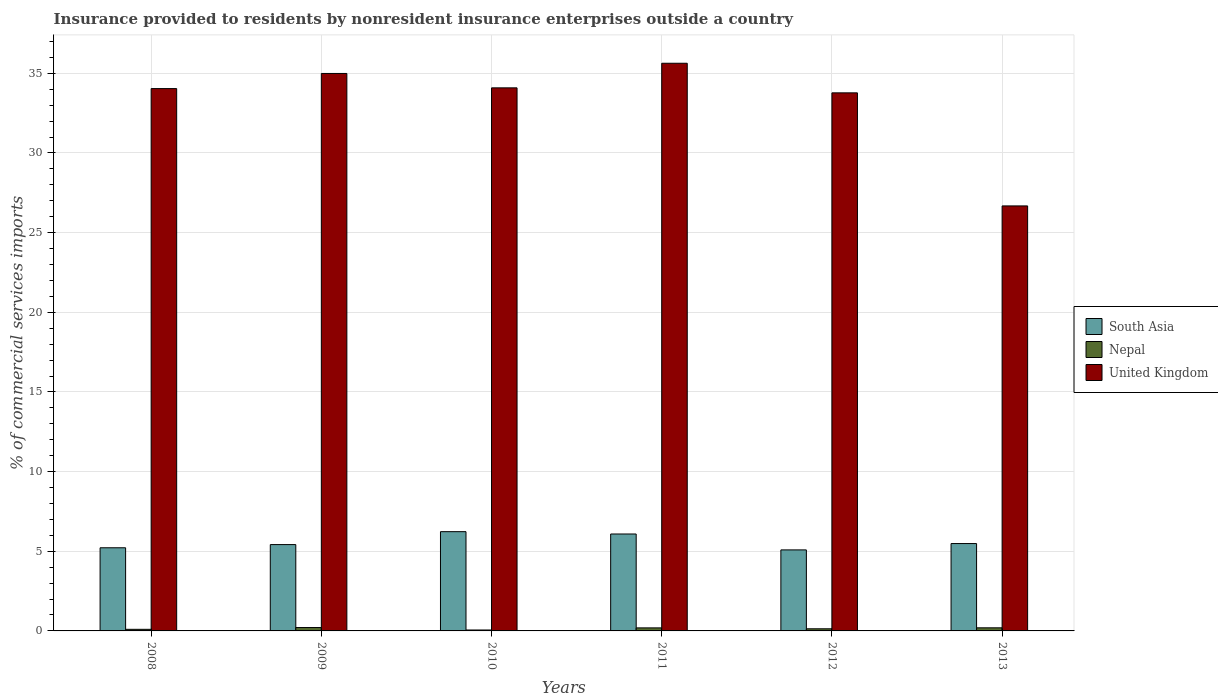How many different coloured bars are there?
Offer a terse response. 3. Are the number of bars per tick equal to the number of legend labels?
Provide a succinct answer. Yes. Are the number of bars on each tick of the X-axis equal?
Give a very brief answer. Yes. How many bars are there on the 3rd tick from the left?
Keep it short and to the point. 3. What is the label of the 2nd group of bars from the left?
Your answer should be very brief. 2009. In how many cases, is the number of bars for a given year not equal to the number of legend labels?
Provide a short and direct response. 0. What is the Insurance provided to residents in United Kingdom in 2008?
Keep it short and to the point. 34.04. Across all years, what is the maximum Insurance provided to residents in South Asia?
Give a very brief answer. 6.23. Across all years, what is the minimum Insurance provided to residents in Nepal?
Give a very brief answer. 0.06. In which year was the Insurance provided to residents in South Asia maximum?
Provide a short and direct response. 2010. In which year was the Insurance provided to residents in United Kingdom minimum?
Provide a succinct answer. 2013. What is the total Insurance provided to residents in Nepal in the graph?
Your response must be concise. 0.89. What is the difference between the Insurance provided to residents in South Asia in 2010 and that in 2012?
Your answer should be very brief. 1.15. What is the difference between the Insurance provided to residents in United Kingdom in 2008 and the Insurance provided to residents in South Asia in 2012?
Provide a short and direct response. 28.96. What is the average Insurance provided to residents in South Asia per year?
Offer a very short reply. 5.59. In the year 2012, what is the difference between the Insurance provided to residents in Nepal and Insurance provided to residents in United Kingdom?
Offer a very short reply. -33.64. What is the ratio of the Insurance provided to residents in United Kingdom in 2012 to that in 2013?
Your answer should be very brief. 1.27. What is the difference between the highest and the second highest Insurance provided to residents in United Kingdom?
Give a very brief answer. 0.64. What is the difference between the highest and the lowest Insurance provided to residents in South Asia?
Make the answer very short. 1.15. In how many years, is the Insurance provided to residents in Nepal greater than the average Insurance provided to residents in Nepal taken over all years?
Give a very brief answer. 3. How many bars are there?
Make the answer very short. 18. Are all the bars in the graph horizontal?
Your answer should be very brief. No. Does the graph contain grids?
Offer a terse response. Yes. How many legend labels are there?
Offer a very short reply. 3. What is the title of the graph?
Keep it short and to the point. Insurance provided to residents by nonresident insurance enterprises outside a country. Does "Haiti" appear as one of the legend labels in the graph?
Your answer should be very brief. No. What is the label or title of the Y-axis?
Offer a very short reply. % of commercial services imports. What is the % of commercial services imports in South Asia in 2008?
Provide a succinct answer. 5.22. What is the % of commercial services imports in Nepal in 2008?
Provide a short and direct response. 0.1. What is the % of commercial services imports in United Kingdom in 2008?
Ensure brevity in your answer.  34.04. What is the % of commercial services imports in South Asia in 2009?
Your response must be concise. 5.42. What is the % of commercial services imports in Nepal in 2009?
Your answer should be very brief. 0.21. What is the % of commercial services imports of United Kingdom in 2009?
Ensure brevity in your answer.  34.99. What is the % of commercial services imports in South Asia in 2010?
Your response must be concise. 6.23. What is the % of commercial services imports in Nepal in 2010?
Your answer should be compact. 0.06. What is the % of commercial services imports of United Kingdom in 2010?
Your answer should be compact. 34.09. What is the % of commercial services imports in South Asia in 2011?
Provide a succinct answer. 6.08. What is the % of commercial services imports of Nepal in 2011?
Provide a succinct answer. 0.19. What is the % of commercial services imports in United Kingdom in 2011?
Ensure brevity in your answer.  35.63. What is the % of commercial services imports of South Asia in 2012?
Your answer should be compact. 5.09. What is the % of commercial services imports in Nepal in 2012?
Ensure brevity in your answer.  0.13. What is the % of commercial services imports of United Kingdom in 2012?
Offer a terse response. 33.77. What is the % of commercial services imports in South Asia in 2013?
Your answer should be compact. 5.48. What is the % of commercial services imports in Nepal in 2013?
Give a very brief answer. 0.2. What is the % of commercial services imports in United Kingdom in 2013?
Provide a succinct answer. 26.68. Across all years, what is the maximum % of commercial services imports of South Asia?
Your answer should be compact. 6.23. Across all years, what is the maximum % of commercial services imports in Nepal?
Provide a succinct answer. 0.21. Across all years, what is the maximum % of commercial services imports of United Kingdom?
Give a very brief answer. 35.63. Across all years, what is the minimum % of commercial services imports of South Asia?
Provide a short and direct response. 5.09. Across all years, what is the minimum % of commercial services imports of Nepal?
Make the answer very short. 0.06. Across all years, what is the minimum % of commercial services imports in United Kingdom?
Your answer should be compact. 26.68. What is the total % of commercial services imports of South Asia in the graph?
Provide a succinct answer. 33.52. What is the total % of commercial services imports in Nepal in the graph?
Keep it short and to the point. 0.89. What is the total % of commercial services imports of United Kingdom in the graph?
Your response must be concise. 199.21. What is the difference between the % of commercial services imports in South Asia in 2008 and that in 2009?
Your answer should be compact. -0.2. What is the difference between the % of commercial services imports of Nepal in 2008 and that in 2009?
Your response must be concise. -0.11. What is the difference between the % of commercial services imports in United Kingdom in 2008 and that in 2009?
Offer a very short reply. -0.95. What is the difference between the % of commercial services imports of South Asia in 2008 and that in 2010?
Your answer should be very brief. -1.01. What is the difference between the % of commercial services imports in Nepal in 2008 and that in 2010?
Your response must be concise. 0.04. What is the difference between the % of commercial services imports in United Kingdom in 2008 and that in 2010?
Provide a short and direct response. -0.05. What is the difference between the % of commercial services imports in South Asia in 2008 and that in 2011?
Your response must be concise. -0.87. What is the difference between the % of commercial services imports of Nepal in 2008 and that in 2011?
Make the answer very short. -0.09. What is the difference between the % of commercial services imports in United Kingdom in 2008 and that in 2011?
Your answer should be compact. -1.59. What is the difference between the % of commercial services imports in South Asia in 2008 and that in 2012?
Ensure brevity in your answer.  0.13. What is the difference between the % of commercial services imports in Nepal in 2008 and that in 2012?
Your answer should be very brief. -0.03. What is the difference between the % of commercial services imports in United Kingdom in 2008 and that in 2012?
Your response must be concise. 0.27. What is the difference between the % of commercial services imports in South Asia in 2008 and that in 2013?
Offer a terse response. -0.26. What is the difference between the % of commercial services imports in Nepal in 2008 and that in 2013?
Ensure brevity in your answer.  -0.09. What is the difference between the % of commercial services imports of United Kingdom in 2008 and that in 2013?
Offer a terse response. 7.36. What is the difference between the % of commercial services imports in South Asia in 2009 and that in 2010?
Provide a succinct answer. -0.81. What is the difference between the % of commercial services imports of Nepal in 2009 and that in 2010?
Make the answer very short. 0.15. What is the difference between the % of commercial services imports in United Kingdom in 2009 and that in 2010?
Your answer should be compact. 0.9. What is the difference between the % of commercial services imports of South Asia in 2009 and that in 2011?
Ensure brevity in your answer.  -0.67. What is the difference between the % of commercial services imports of Nepal in 2009 and that in 2011?
Keep it short and to the point. 0.02. What is the difference between the % of commercial services imports in United Kingdom in 2009 and that in 2011?
Keep it short and to the point. -0.64. What is the difference between the % of commercial services imports of South Asia in 2009 and that in 2012?
Keep it short and to the point. 0.33. What is the difference between the % of commercial services imports of Nepal in 2009 and that in 2012?
Your answer should be compact. 0.08. What is the difference between the % of commercial services imports in United Kingdom in 2009 and that in 2012?
Your answer should be very brief. 1.22. What is the difference between the % of commercial services imports of South Asia in 2009 and that in 2013?
Offer a terse response. -0.06. What is the difference between the % of commercial services imports in Nepal in 2009 and that in 2013?
Provide a succinct answer. 0.02. What is the difference between the % of commercial services imports of United Kingdom in 2009 and that in 2013?
Give a very brief answer. 8.31. What is the difference between the % of commercial services imports in South Asia in 2010 and that in 2011?
Provide a succinct answer. 0.15. What is the difference between the % of commercial services imports in Nepal in 2010 and that in 2011?
Ensure brevity in your answer.  -0.13. What is the difference between the % of commercial services imports in United Kingdom in 2010 and that in 2011?
Make the answer very short. -1.54. What is the difference between the % of commercial services imports in South Asia in 2010 and that in 2012?
Your answer should be very brief. 1.15. What is the difference between the % of commercial services imports of Nepal in 2010 and that in 2012?
Keep it short and to the point. -0.07. What is the difference between the % of commercial services imports of United Kingdom in 2010 and that in 2012?
Your answer should be very brief. 0.31. What is the difference between the % of commercial services imports in South Asia in 2010 and that in 2013?
Your answer should be compact. 0.75. What is the difference between the % of commercial services imports of Nepal in 2010 and that in 2013?
Make the answer very short. -0.14. What is the difference between the % of commercial services imports in United Kingdom in 2010 and that in 2013?
Offer a very short reply. 7.41. What is the difference between the % of commercial services imports in Nepal in 2011 and that in 2012?
Your answer should be compact. 0.06. What is the difference between the % of commercial services imports of United Kingdom in 2011 and that in 2012?
Ensure brevity in your answer.  1.86. What is the difference between the % of commercial services imports of South Asia in 2011 and that in 2013?
Offer a very short reply. 0.6. What is the difference between the % of commercial services imports of Nepal in 2011 and that in 2013?
Provide a succinct answer. -0. What is the difference between the % of commercial services imports of United Kingdom in 2011 and that in 2013?
Your answer should be compact. 8.95. What is the difference between the % of commercial services imports of South Asia in 2012 and that in 2013?
Provide a succinct answer. -0.4. What is the difference between the % of commercial services imports in Nepal in 2012 and that in 2013?
Your answer should be compact. -0.06. What is the difference between the % of commercial services imports of United Kingdom in 2012 and that in 2013?
Ensure brevity in your answer.  7.1. What is the difference between the % of commercial services imports of South Asia in 2008 and the % of commercial services imports of Nepal in 2009?
Offer a terse response. 5.01. What is the difference between the % of commercial services imports of South Asia in 2008 and the % of commercial services imports of United Kingdom in 2009?
Your answer should be compact. -29.77. What is the difference between the % of commercial services imports in Nepal in 2008 and the % of commercial services imports in United Kingdom in 2009?
Give a very brief answer. -34.89. What is the difference between the % of commercial services imports of South Asia in 2008 and the % of commercial services imports of Nepal in 2010?
Provide a succinct answer. 5.16. What is the difference between the % of commercial services imports of South Asia in 2008 and the % of commercial services imports of United Kingdom in 2010?
Ensure brevity in your answer.  -28.87. What is the difference between the % of commercial services imports in Nepal in 2008 and the % of commercial services imports in United Kingdom in 2010?
Provide a short and direct response. -33.99. What is the difference between the % of commercial services imports of South Asia in 2008 and the % of commercial services imports of Nepal in 2011?
Your response must be concise. 5.03. What is the difference between the % of commercial services imports in South Asia in 2008 and the % of commercial services imports in United Kingdom in 2011?
Offer a very short reply. -30.41. What is the difference between the % of commercial services imports of Nepal in 2008 and the % of commercial services imports of United Kingdom in 2011?
Provide a succinct answer. -35.53. What is the difference between the % of commercial services imports of South Asia in 2008 and the % of commercial services imports of Nepal in 2012?
Offer a very short reply. 5.09. What is the difference between the % of commercial services imports in South Asia in 2008 and the % of commercial services imports in United Kingdom in 2012?
Keep it short and to the point. -28.56. What is the difference between the % of commercial services imports in Nepal in 2008 and the % of commercial services imports in United Kingdom in 2012?
Provide a short and direct response. -33.67. What is the difference between the % of commercial services imports in South Asia in 2008 and the % of commercial services imports in Nepal in 2013?
Provide a short and direct response. 5.02. What is the difference between the % of commercial services imports of South Asia in 2008 and the % of commercial services imports of United Kingdom in 2013?
Give a very brief answer. -21.46. What is the difference between the % of commercial services imports in Nepal in 2008 and the % of commercial services imports in United Kingdom in 2013?
Your answer should be very brief. -26.58. What is the difference between the % of commercial services imports of South Asia in 2009 and the % of commercial services imports of Nepal in 2010?
Your answer should be compact. 5.36. What is the difference between the % of commercial services imports in South Asia in 2009 and the % of commercial services imports in United Kingdom in 2010?
Offer a terse response. -28.67. What is the difference between the % of commercial services imports in Nepal in 2009 and the % of commercial services imports in United Kingdom in 2010?
Make the answer very short. -33.88. What is the difference between the % of commercial services imports of South Asia in 2009 and the % of commercial services imports of Nepal in 2011?
Provide a succinct answer. 5.23. What is the difference between the % of commercial services imports of South Asia in 2009 and the % of commercial services imports of United Kingdom in 2011?
Offer a very short reply. -30.21. What is the difference between the % of commercial services imports in Nepal in 2009 and the % of commercial services imports in United Kingdom in 2011?
Keep it short and to the point. -35.42. What is the difference between the % of commercial services imports of South Asia in 2009 and the % of commercial services imports of Nepal in 2012?
Offer a terse response. 5.29. What is the difference between the % of commercial services imports in South Asia in 2009 and the % of commercial services imports in United Kingdom in 2012?
Make the answer very short. -28.36. What is the difference between the % of commercial services imports in Nepal in 2009 and the % of commercial services imports in United Kingdom in 2012?
Offer a very short reply. -33.56. What is the difference between the % of commercial services imports in South Asia in 2009 and the % of commercial services imports in Nepal in 2013?
Your answer should be compact. 5.22. What is the difference between the % of commercial services imports of South Asia in 2009 and the % of commercial services imports of United Kingdom in 2013?
Keep it short and to the point. -21.26. What is the difference between the % of commercial services imports in Nepal in 2009 and the % of commercial services imports in United Kingdom in 2013?
Offer a terse response. -26.47. What is the difference between the % of commercial services imports in South Asia in 2010 and the % of commercial services imports in Nepal in 2011?
Provide a succinct answer. 6.04. What is the difference between the % of commercial services imports of South Asia in 2010 and the % of commercial services imports of United Kingdom in 2011?
Provide a succinct answer. -29.4. What is the difference between the % of commercial services imports of Nepal in 2010 and the % of commercial services imports of United Kingdom in 2011?
Your response must be concise. -35.57. What is the difference between the % of commercial services imports of South Asia in 2010 and the % of commercial services imports of Nepal in 2012?
Ensure brevity in your answer.  6.1. What is the difference between the % of commercial services imports in South Asia in 2010 and the % of commercial services imports in United Kingdom in 2012?
Keep it short and to the point. -27.54. What is the difference between the % of commercial services imports in Nepal in 2010 and the % of commercial services imports in United Kingdom in 2012?
Your answer should be compact. -33.72. What is the difference between the % of commercial services imports in South Asia in 2010 and the % of commercial services imports in Nepal in 2013?
Your response must be concise. 6.04. What is the difference between the % of commercial services imports in South Asia in 2010 and the % of commercial services imports in United Kingdom in 2013?
Make the answer very short. -20.45. What is the difference between the % of commercial services imports in Nepal in 2010 and the % of commercial services imports in United Kingdom in 2013?
Offer a terse response. -26.62. What is the difference between the % of commercial services imports of South Asia in 2011 and the % of commercial services imports of Nepal in 2012?
Offer a terse response. 5.95. What is the difference between the % of commercial services imports of South Asia in 2011 and the % of commercial services imports of United Kingdom in 2012?
Provide a succinct answer. -27.69. What is the difference between the % of commercial services imports in Nepal in 2011 and the % of commercial services imports in United Kingdom in 2012?
Offer a terse response. -33.58. What is the difference between the % of commercial services imports of South Asia in 2011 and the % of commercial services imports of Nepal in 2013?
Make the answer very short. 5.89. What is the difference between the % of commercial services imports in South Asia in 2011 and the % of commercial services imports in United Kingdom in 2013?
Keep it short and to the point. -20.59. What is the difference between the % of commercial services imports of Nepal in 2011 and the % of commercial services imports of United Kingdom in 2013?
Ensure brevity in your answer.  -26.49. What is the difference between the % of commercial services imports in South Asia in 2012 and the % of commercial services imports in Nepal in 2013?
Your response must be concise. 4.89. What is the difference between the % of commercial services imports of South Asia in 2012 and the % of commercial services imports of United Kingdom in 2013?
Make the answer very short. -21.59. What is the difference between the % of commercial services imports of Nepal in 2012 and the % of commercial services imports of United Kingdom in 2013?
Your response must be concise. -26.54. What is the average % of commercial services imports in South Asia per year?
Your response must be concise. 5.59. What is the average % of commercial services imports of Nepal per year?
Ensure brevity in your answer.  0.15. What is the average % of commercial services imports of United Kingdom per year?
Provide a succinct answer. 33.2. In the year 2008, what is the difference between the % of commercial services imports in South Asia and % of commercial services imports in Nepal?
Your answer should be very brief. 5.12. In the year 2008, what is the difference between the % of commercial services imports in South Asia and % of commercial services imports in United Kingdom?
Your response must be concise. -28.82. In the year 2008, what is the difference between the % of commercial services imports in Nepal and % of commercial services imports in United Kingdom?
Offer a terse response. -33.94. In the year 2009, what is the difference between the % of commercial services imports in South Asia and % of commercial services imports in Nepal?
Keep it short and to the point. 5.21. In the year 2009, what is the difference between the % of commercial services imports in South Asia and % of commercial services imports in United Kingdom?
Ensure brevity in your answer.  -29.57. In the year 2009, what is the difference between the % of commercial services imports of Nepal and % of commercial services imports of United Kingdom?
Give a very brief answer. -34.78. In the year 2010, what is the difference between the % of commercial services imports in South Asia and % of commercial services imports in Nepal?
Your answer should be very brief. 6.17. In the year 2010, what is the difference between the % of commercial services imports in South Asia and % of commercial services imports in United Kingdom?
Provide a succinct answer. -27.86. In the year 2010, what is the difference between the % of commercial services imports of Nepal and % of commercial services imports of United Kingdom?
Keep it short and to the point. -34.03. In the year 2011, what is the difference between the % of commercial services imports of South Asia and % of commercial services imports of Nepal?
Offer a terse response. 5.89. In the year 2011, what is the difference between the % of commercial services imports of South Asia and % of commercial services imports of United Kingdom?
Make the answer very short. -29.55. In the year 2011, what is the difference between the % of commercial services imports in Nepal and % of commercial services imports in United Kingdom?
Keep it short and to the point. -35.44. In the year 2012, what is the difference between the % of commercial services imports in South Asia and % of commercial services imports in Nepal?
Offer a terse response. 4.95. In the year 2012, what is the difference between the % of commercial services imports in South Asia and % of commercial services imports in United Kingdom?
Your answer should be very brief. -28.69. In the year 2012, what is the difference between the % of commercial services imports in Nepal and % of commercial services imports in United Kingdom?
Provide a short and direct response. -33.64. In the year 2013, what is the difference between the % of commercial services imports in South Asia and % of commercial services imports in Nepal?
Give a very brief answer. 5.29. In the year 2013, what is the difference between the % of commercial services imports of South Asia and % of commercial services imports of United Kingdom?
Give a very brief answer. -21.19. In the year 2013, what is the difference between the % of commercial services imports in Nepal and % of commercial services imports in United Kingdom?
Your response must be concise. -26.48. What is the ratio of the % of commercial services imports of South Asia in 2008 to that in 2009?
Offer a terse response. 0.96. What is the ratio of the % of commercial services imports in Nepal in 2008 to that in 2009?
Your answer should be very brief. 0.47. What is the ratio of the % of commercial services imports in United Kingdom in 2008 to that in 2009?
Provide a succinct answer. 0.97. What is the ratio of the % of commercial services imports in South Asia in 2008 to that in 2010?
Give a very brief answer. 0.84. What is the ratio of the % of commercial services imports of Nepal in 2008 to that in 2010?
Keep it short and to the point. 1.71. What is the ratio of the % of commercial services imports of United Kingdom in 2008 to that in 2010?
Make the answer very short. 1. What is the ratio of the % of commercial services imports of South Asia in 2008 to that in 2011?
Provide a short and direct response. 0.86. What is the ratio of the % of commercial services imports in Nepal in 2008 to that in 2011?
Your answer should be very brief. 0.52. What is the ratio of the % of commercial services imports in United Kingdom in 2008 to that in 2011?
Ensure brevity in your answer.  0.96. What is the ratio of the % of commercial services imports in South Asia in 2008 to that in 2012?
Ensure brevity in your answer.  1.03. What is the ratio of the % of commercial services imports of United Kingdom in 2008 to that in 2012?
Your answer should be very brief. 1.01. What is the ratio of the % of commercial services imports in South Asia in 2008 to that in 2013?
Ensure brevity in your answer.  0.95. What is the ratio of the % of commercial services imports in Nepal in 2008 to that in 2013?
Give a very brief answer. 0.51. What is the ratio of the % of commercial services imports in United Kingdom in 2008 to that in 2013?
Offer a terse response. 1.28. What is the ratio of the % of commercial services imports of South Asia in 2009 to that in 2010?
Ensure brevity in your answer.  0.87. What is the ratio of the % of commercial services imports in Nepal in 2009 to that in 2010?
Your answer should be compact. 3.63. What is the ratio of the % of commercial services imports of United Kingdom in 2009 to that in 2010?
Your answer should be compact. 1.03. What is the ratio of the % of commercial services imports of South Asia in 2009 to that in 2011?
Make the answer very short. 0.89. What is the ratio of the % of commercial services imports of Nepal in 2009 to that in 2011?
Provide a short and direct response. 1.11. What is the ratio of the % of commercial services imports in United Kingdom in 2009 to that in 2011?
Offer a very short reply. 0.98. What is the ratio of the % of commercial services imports of South Asia in 2009 to that in 2012?
Ensure brevity in your answer.  1.07. What is the ratio of the % of commercial services imports of Nepal in 2009 to that in 2012?
Your response must be concise. 1.59. What is the ratio of the % of commercial services imports in United Kingdom in 2009 to that in 2012?
Your response must be concise. 1.04. What is the ratio of the % of commercial services imports in South Asia in 2009 to that in 2013?
Offer a terse response. 0.99. What is the ratio of the % of commercial services imports in Nepal in 2009 to that in 2013?
Offer a terse response. 1.09. What is the ratio of the % of commercial services imports in United Kingdom in 2009 to that in 2013?
Your response must be concise. 1.31. What is the ratio of the % of commercial services imports in Nepal in 2010 to that in 2011?
Your response must be concise. 0.31. What is the ratio of the % of commercial services imports of United Kingdom in 2010 to that in 2011?
Your answer should be very brief. 0.96. What is the ratio of the % of commercial services imports in South Asia in 2010 to that in 2012?
Provide a short and direct response. 1.23. What is the ratio of the % of commercial services imports in Nepal in 2010 to that in 2012?
Offer a terse response. 0.44. What is the ratio of the % of commercial services imports of United Kingdom in 2010 to that in 2012?
Give a very brief answer. 1.01. What is the ratio of the % of commercial services imports in South Asia in 2010 to that in 2013?
Give a very brief answer. 1.14. What is the ratio of the % of commercial services imports of Nepal in 2010 to that in 2013?
Your response must be concise. 0.3. What is the ratio of the % of commercial services imports of United Kingdom in 2010 to that in 2013?
Your answer should be very brief. 1.28. What is the ratio of the % of commercial services imports of South Asia in 2011 to that in 2012?
Offer a terse response. 1.2. What is the ratio of the % of commercial services imports of Nepal in 2011 to that in 2012?
Make the answer very short. 1.43. What is the ratio of the % of commercial services imports of United Kingdom in 2011 to that in 2012?
Ensure brevity in your answer.  1.05. What is the ratio of the % of commercial services imports in South Asia in 2011 to that in 2013?
Keep it short and to the point. 1.11. What is the ratio of the % of commercial services imports of Nepal in 2011 to that in 2013?
Offer a terse response. 0.98. What is the ratio of the % of commercial services imports of United Kingdom in 2011 to that in 2013?
Ensure brevity in your answer.  1.34. What is the ratio of the % of commercial services imports in South Asia in 2012 to that in 2013?
Keep it short and to the point. 0.93. What is the ratio of the % of commercial services imports in Nepal in 2012 to that in 2013?
Offer a terse response. 0.68. What is the ratio of the % of commercial services imports of United Kingdom in 2012 to that in 2013?
Provide a short and direct response. 1.27. What is the difference between the highest and the second highest % of commercial services imports in South Asia?
Keep it short and to the point. 0.15. What is the difference between the highest and the second highest % of commercial services imports of Nepal?
Make the answer very short. 0.02. What is the difference between the highest and the second highest % of commercial services imports of United Kingdom?
Offer a very short reply. 0.64. What is the difference between the highest and the lowest % of commercial services imports in South Asia?
Offer a very short reply. 1.15. What is the difference between the highest and the lowest % of commercial services imports in Nepal?
Provide a succinct answer. 0.15. What is the difference between the highest and the lowest % of commercial services imports of United Kingdom?
Your answer should be compact. 8.95. 